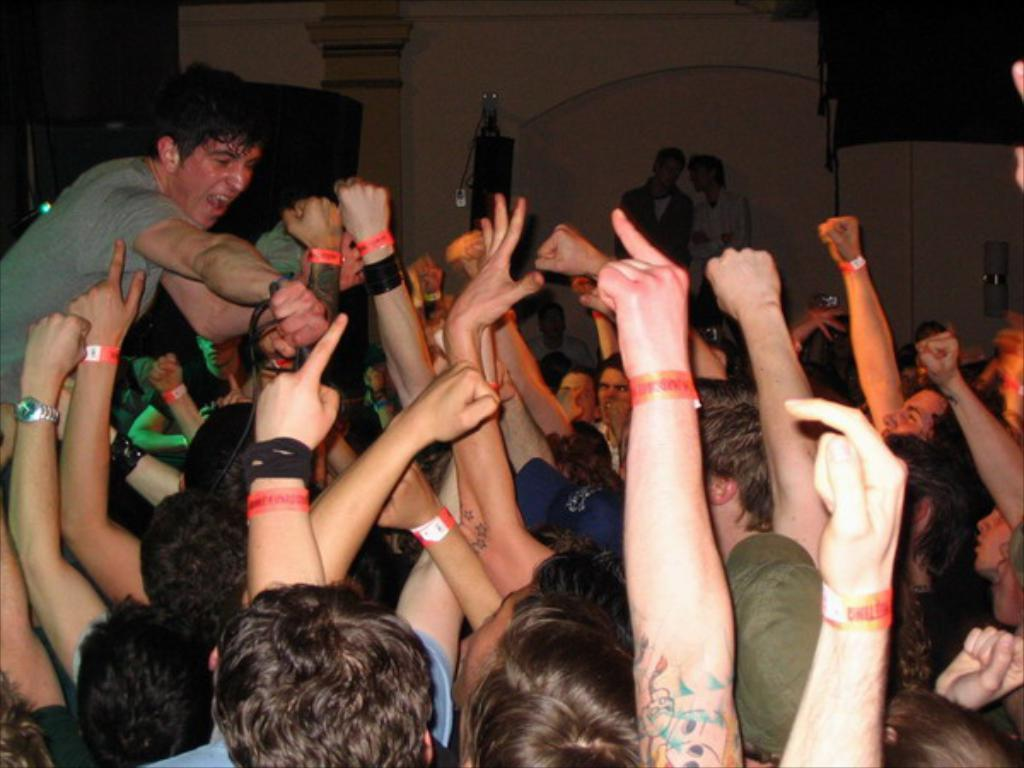How many people are in the image? There is a group of people in the image, but the exact number cannot be determined from the provided facts. What is the object behind the people? The facts do not specify the nature of the object behind the people, so we cannot describe it. What is the wall visible in the image made of? The facts do not mention the material of the wall, so we cannot determine its composition. What type of glue is being used to hold the farm together in the image? There is no farm or glue present in the image. 